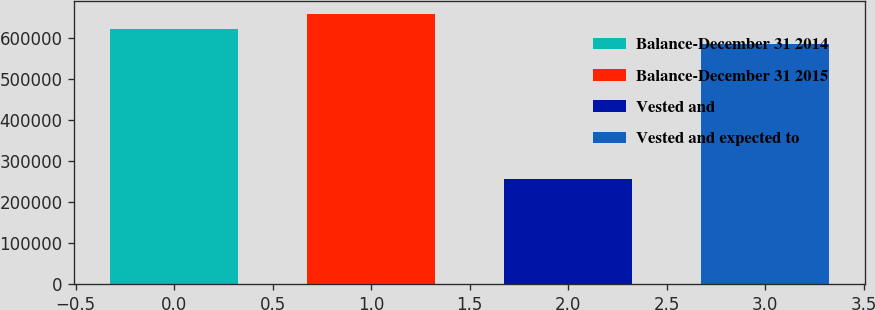Convert chart. <chart><loc_0><loc_0><loc_500><loc_500><bar_chart><fcel>Balance-December 31 2014<fcel>Balance-December 31 2015<fcel>Vested and<fcel>Vested and expected to<nl><fcel>622268<fcel>658809<fcel>255392<fcel>585727<nl></chart> 